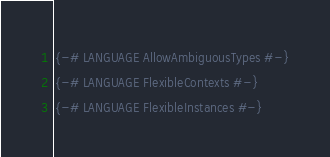Convert code to text. <code><loc_0><loc_0><loc_500><loc_500><_Haskell_>{-# LANGUAGE AllowAmbiguousTypes #-}
{-# LANGUAGE FlexibleContexts #-}
{-# LANGUAGE FlexibleInstances #-}</code> 